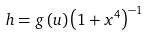<formula> <loc_0><loc_0><loc_500><loc_500>h = g \left ( u \right ) \left ( 1 + x ^ { 4 } \right ) ^ { - 1 }</formula> 